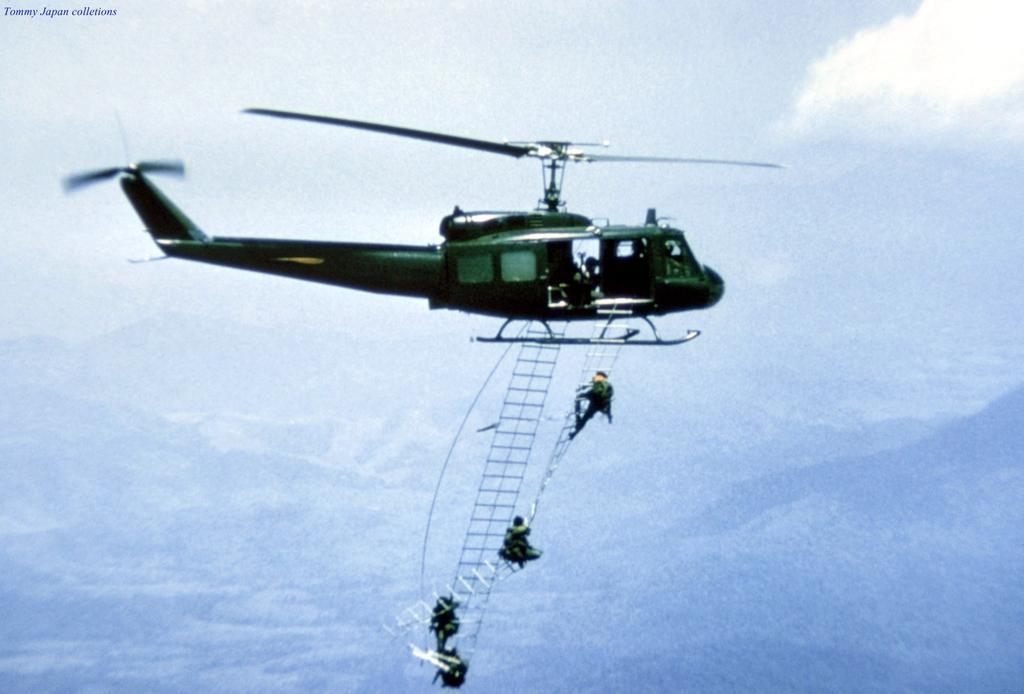Can you describe this image briefly? In this image I see an helicopter which is of green in color and I see the ladders over here on which there are 4 persons and I see the sky and I see a watermark over here. 